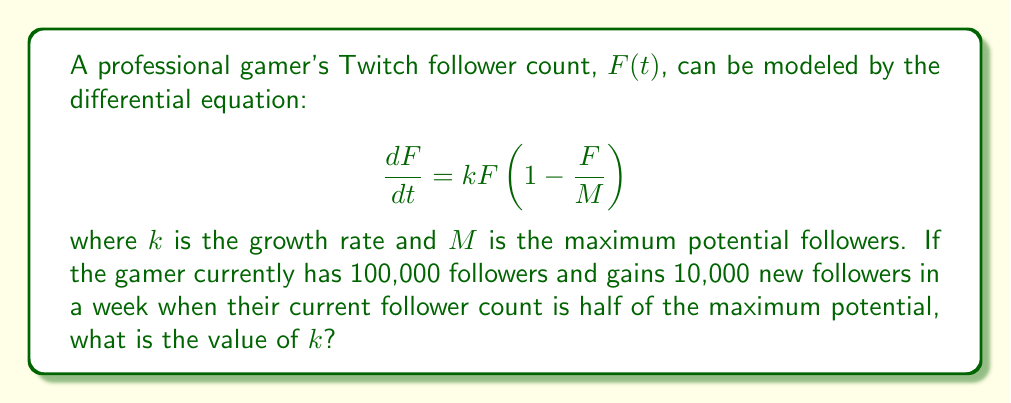Solve this math problem. Let's approach this step-by-step:

1) We're given the logistic growth model:
   $$\frac{dF}{dt} = kF(1-\frac{F}{M})$$

2) We know that when $F = \frac{M}{2}$ (half of the maximum potential), the gamer gains 10,000 followers in a week.

3) Let's substitute these values into our equation:
   $$10,000 = k(\frac{M}{2})(1-\frac{\frac{M}{2}}{M})$$

4) Simplify the right side:
   $$10,000 = k(\frac{M}{2})(1-\frac{1}{2}) = k(\frac{M}{2})(\frac{1}{2}) = k\frac{M}{4}$$

5) We don't know $M$, but we can find it. We're told the current follower count is 100,000, which is half of $M$. So:
   $$M = 200,000$$

6) Substitute this back into our equation:
   $$10,000 = k\frac{200,000}{4} = 50,000k$$

7) Solve for $k$:
   $$k = \frac{10,000}{50,000} = \frac{1}{5} = 0.2$$

Thus, the growth rate $k$ is 0.2 per week.
Answer: $k = 0.2$ per week 